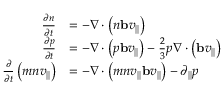<formula> <loc_0><loc_0><loc_500><loc_500>\begin{array} { r l } { \frac { \partial n } { \partial t } } & { = - \nabla \cdot \left ( n b v _ { | | } \right ) } \\ { \frac { \partial p } { \partial t } } & { = - \nabla \cdot \left ( p b v _ { | | } \right ) - \frac { 2 } { 3 } p \nabla \cdot \left ( b v _ { | | } \right ) } \\ { \frac { \partial } { \partial t } \left ( m n v _ { | | } \right ) } & { = - \nabla \cdot \left ( m n v _ { | | } b v _ { | | } \right ) - \partial _ { | | } p } \end{array}</formula> 